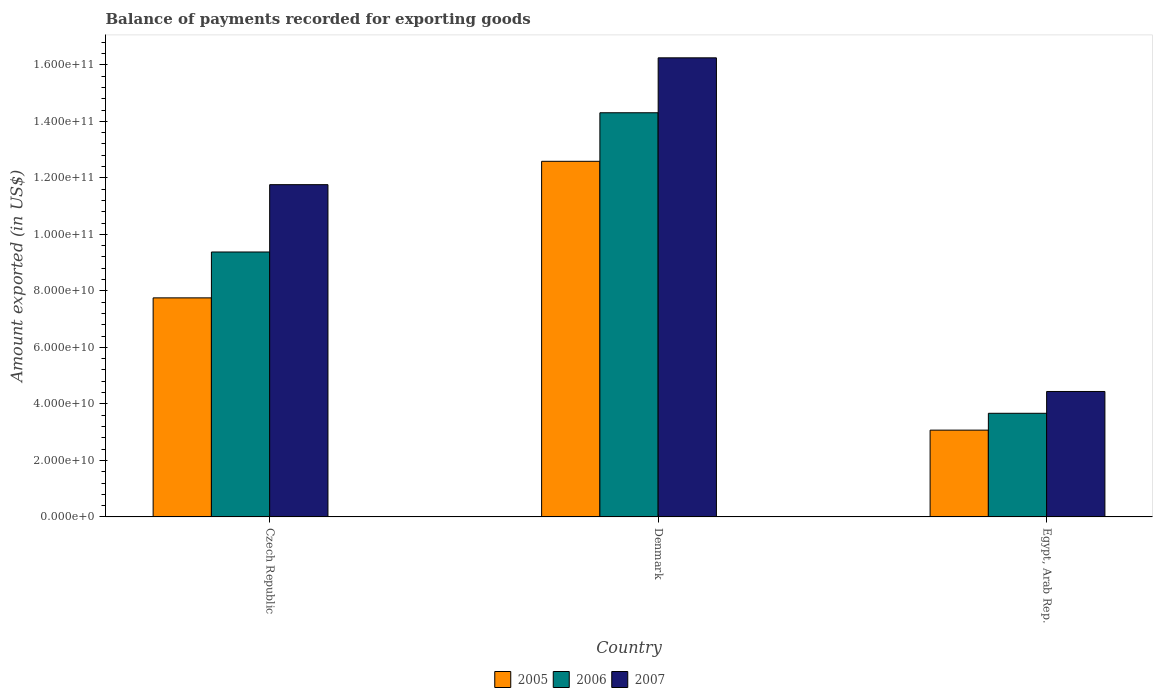How many different coloured bars are there?
Your answer should be very brief. 3. Are the number of bars per tick equal to the number of legend labels?
Your answer should be compact. Yes. How many bars are there on the 2nd tick from the left?
Ensure brevity in your answer.  3. What is the label of the 3rd group of bars from the left?
Your answer should be compact. Egypt, Arab Rep. What is the amount exported in 2005 in Czech Republic?
Ensure brevity in your answer.  7.75e+1. Across all countries, what is the maximum amount exported in 2007?
Give a very brief answer. 1.62e+11. Across all countries, what is the minimum amount exported in 2006?
Keep it short and to the point. 3.67e+1. In which country was the amount exported in 2006 maximum?
Your response must be concise. Denmark. In which country was the amount exported in 2006 minimum?
Offer a terse response. Egypt, Arab Rep. What is the total amount exported in 2005 in the graph?
Keep it short and to the point. 2.34e+11. What is the difference between the amount exported in 2005 in Czech Republic and that in Denmark?
Offer a very short reply. -4.83e+1. What is the difference between the amount exported in 2005 in Egypt, Arab Rep. and the amount exported in 2006 in Czech Republic?
Offer a very short reply. -6.30e+1. What is the average amount exported in 2007 per country?
Your answer should be very brief. 1.08e+11. What is the difference between the amount exported of/in 2006 and amount exported of/in 2005 in Denmark?
Your response must be concise. 1.72e+1. What is the ratio of the amount exported in 2006 in Denmark to that in Egypt, Arab Rep.?
Ensure brevity in your answer.  3.9. Is the amount exported in 2007 in Czech Republic less than that in Denmark?
Make the answer very short. Yes. What is the difference between the highest and the second highest amount exported in 2007?
Your response must be concise. 4.49e+1. What is the difference between the highest and the lowest amount exported in 2007?
Provide a short and direct response. 1.18e+11. In how many countries, is the amount exported in 2005 greater than the average amount exported in 2005 taken over all countries?
Your response must be concise. 1. What does the 2nd bar from the left in Denmark represents?
Provide a succinct answer. 2006. What does the 1st bar from the right in Denmark represents?
Provide a short and direct response. 2007. Is it the case that in every country, the sum of the amount exported in 2006 and amount exported in 2005 is greater than the amount exported in 2007?
Make the answer very short. Yes. Are all the bars in the graph horizontal?
Keep it short and to the point. No. How many countries are there in the graph?
Provide a short and direct response. 3. Does the graph contain any zero values?
Provide a short and direct response. No. Does the graph contain grids?
Your answer should be very brief. No. Where does the legend appear in the graph?
Provide a succinct answer. Bottom center. What is the title of the graph?
Offer a terse response. Balance of payments recorded for exporting goods. What is the label or title of the Y-axis?
Give a very brief answer. Amount exported (in US$). What is the Amount exported (in US$) of 2005 in Czech Republic?
Your answer should be compact. 7.75e+1. What is the Amount exported (in US$) in 2006 in Czech Republic?
Your answer should be compact. 9.38e+1. What is the Amount exported (in US$) of 2007 in Czech Republic?
Your answer should be very brief. 1.18e+11. What is the Amount exported (in US$) of 2005 in Denmark?
Offer a terse response. 1.26e+11. What is the Amount exported (in US$) in 2006 in Denmark?
Offer a very short reply. 1.43e+11. What is the Amount exported (in US$) of 2007 in Denmark?
Give a very brief answer. 1.62e+11. What is the Amount exported (in US$) of 2005 in Egypt, Arab Rep.?
Provide a short and direct response. 3.07e+1. What is the Amount exported (in US$) of 2006 in Egypt, Arab Rep.?
Ensure brevity in your answer.  3.67e+1. What is the Amount exported (in US$) in 2007 in Egypt, Arab Rep.?
Keep it short and to the point. 4.44e+1. Across all countries, what is the maximum Amount exported (in US$) of 2005?
Give a very brief answer. 1.26e+11. Across all countries, what is the maximum Amount exported (in US$) of 2006?
Provide a short and direct response. 1.43e+11. Across all countries, what is the maximum Amount exported (in US$) of 2007?
Provide a short and direct response. 1.62e+11. Across all countries, what is the minimum Amount exported (in US$) in 2005?
Ensure brevity in your answer.  3.07e+1. Across all countries, what is the minimum Amount exported (in US$) of 2006?
Give a very brief answer. 3.67e+1. Across all countries, what is the minimum Amount exported (in US$) in 2007?
Your answer should be very brief. 4.44e+1. What is the total Amount exported (in US$) of 2005 in the graph?
Offer a very short reply. 2.34e+11. What is the total Amount exported (in US$) of 2006 in the graph?
Your response must be concise. 2.73e+11. What is the total Amount exported (in US$) of 2007 in the graph?
Your answer should be very brief. 3.24e+11. What is the difference between the Amount exported (in US$) of 2005 in Czech Republic and that in Denmark?
Your response must be concise. -4.83e+1. What is the difference between the Amount exported (in US$) in 2006 in Czech Republic and that in Denmark?
Provide a succinct answer. -4.93e+1. What is the difference between the Amount exported (in US$) of 2007 in Czech Republic and that in Denmark?
Give a very brief answer. -4.49e+1. What is the difference between the Amount exported (in US$) in 2005 in Czech Republic and that in Egypt, Arab Rep.?
Provide a succinct answer. 4.68e+1. What is the difference between the Amount exported (in US$) in 2006 in Czech Republic and that in Egypt, Arab Rep.?
Your response must be concise. 5.71e+1. What is the difference between the Amount exported (in US$) of 2007 in Czech Republic and that in Egypt, Arab Rep.?
Offer a terse response. 7.32e+1. What is the difference between the Amount exported (in US$) of 2005 in Denmark and that in Egypt, Arab Rep.?
Offer a terse response. 9.51e+1. What is the difference between the Amount exported (in US$) of 2006 in Denmark and that in Egypt, Arab Rep.?
Provide a succinct answer. 1.06e+11. What is the difference between the Amount exported (in US$) of 2007 in Denmark and that in Egypt, Arab Rep.?
Your answer should be compact. 1.18e+11. What is the difference between the Amount exported (in US$) of 2005 in Czech Republic and the Amount exported (in US$) of 2006 in Denmark?
Your response must be concise. -6.55e+1. What is the difference between the Amount exported (in US$) in 2005 in Czech Republic and the Amount exported (in US$) in 2007 in Denmark?
Ensure brevity in your answer.  -8.50e+1. What is the difference between the Amount exported (in US$) in 2006 in Czech Republic and the Amount exported (in US$) in 2007 in Denmark?
Offer a terse response. -6.87e+1. What is the difference between the Amount exported (in US$) of 2005 in Czech Republic and the Amount exported (in US$) of 2006 in Egypt, Arab Rep.?
Your answer should be very brief. 4.08e+1. What is the difference between the Amount exported (in US$) of 2005 in Czech Republic and the Amount exported (in US$) of 2007 in Egypt, Arab Rep.?
Ensure brevity in your answer.  3.31e+1. What is the difference between the Amount exported (in US$) of 2006 in Czech Republic and the Amount exported (in US$) of 2007 in Egypt, Arab Rep.?
Provide a succinct answer. 4.94e+1. What is the difference between the Amount exported (in US$) of 2005 in Denmark and the Amount exported (in US$) of 2006 in Egypt, Arab Rep.?
Give a very brief answer. 8.92e+1. What is the difference between the Amount exported (in US$) of 2005 in Denmark and the Amount exported (in US$) of 2007 in Egypt, Arab Rep.?
Give a very brief answer. 8.15e+1. What is the difference between the Amount exported (in US$) of 2006 in Denmark and the Amount exported (in US$) of 2007 in Egypt, Arab Rep.?
Your response must be concise. 9.86e+1. What is the average Amount exported (in US$) of 2005 per country?
Your answer should be compact. 7.80e+1. What is the average Amount exported (in US$) in 2006 per country?
Make the answer very short. 9.12e+1. What is the average Amount exported (in US$) of 2007 per country?
Your response must be concise. 1.08e+11. What is the difference between the Amount exported (in US$) in 2005 and Amount exported (in US$) in 2006 in Czech Republic?
Provide a short and direct response. -1.62e+1. What is the difference between the Amount exported (in US$) of 2005 and Amount exported (in US$) of 2007 in Czech Republic?
Give a very brief answer. -4.01e+1. What is the difference between the Amount exported (in US$) in 2006 and Amount exported (in US$) in 2007 in Czech Republic?
Your answer should be very brief. -2.38e+1. What is the difference between the Amount exported (in US$) of 2005 and Amount exported (in US$) of 2006 in Denmark?
Keep it short and to the point. -1.72e+1. What is the difference between the Amount exported (in US$) of 2005 and Amount exported (in US$) of 2007 in Denmark?
Offer a very short reply. -3.66e+1. What is the difference between the Amount exported (in US$) of 2006 and Amount exported (in US$) of 2007 in Denmark?
Your response must be concise. -1.94e+1. What is the difference between the Amount exported (in US$) in 2005 and Amount exported (in US$) in 2006 in Egypt, Arab Rep.?
Keep it short and to the point. -5.96e+09. What is the difference between the Amount exported (in US$) in 2005 and Amount exported (in US$) in 2007 in Egypt, Arab Rep.?
Offer a terse response. -1.37e+1. What is the difference between the Amount exported (in US$) in 2006 and Amount exported (in US$) in 2007 in Egypt, Arab Rep.?
Offer a terse response. -7.72e+09. What is the ratio of the Amount exported (in US$) of 2005 in Czech Republic to that in Denmark?
Provide a short and direct response. 0.62. What is the ratio of the Amount exported (in US$) in 2006 in Czech Republic to that in Denmark?
Give a very brief answer. 0.66. What is the ratio of the Amount exported (in US$) in 2007 in Czech Republic to that in Denmark?
Make the answer very short. 0.72. What is the ratio of the Amount exported (in US$) of 2005 in Czech Republic to that in Egypt, Arab Rep.?
Provide a short and direct response. 2.52. What is the ratio of the Amount exported (in US$) of 2006 in Czech Republic to that in Egypt, Arab Rep.?
Your response must be concise. 2.56. What is the ratio of the Amount exported (in US$) in 2007 in Czech Republic to that in Egypt, Arab Rep.?
Provide a short and direct response. 2.65. What is the ratio of the Amount exported (in US$) of 2005 in Denmark to that in Egypt, Arab Rep.?
Make the answer very short. 4.1. What is the ratio of the Amount exported (in US$) in 2006 in Denmark to that in Egypt, Arab Rep.?
Make the answer very short. 3.9. What is the ratio of the Amount exported (in US$) in 2007 in Denmark to that in Egypt, Arab Rep.?
Make the answer very short. 3.66. What is the difference between the highest and the second highest Amount exported (in US$) in 2005?
Offer a terse response. 4.83e+1. What is the difference between the highest and the second highest Amount exported (in US$) in 2006?
Make the answer very short. 4.93e+1. What is the difference between the highest and the second highest Amount exported (in US$) in 2007?
Provide a short and direct response. 4.49e+1. What is the difference between the highest and the lowest Amount exported (in US$) in 2005?
Ensure brevity in your answer.  9.51e+1. What is the difference between the highest and the lowest Amount exported (in US$) of 2006?
Offer a very short reply. 1.06e+11. What is the difference between the highest and the lowest Amount exported (in US$) in 2007?
Provide a succinct answer. 1.18e+11. 